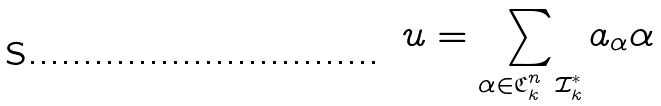Convert formula to latex. <formula><loc_0><loc_0><loc_500><loc_500>u = \sum _ { \alpha \in \mathfrak { C } _ { k } ^ { n } \ \mathcal { I } ^ { * } _ { k } } a _ { \alpha } \alpha</formula> 